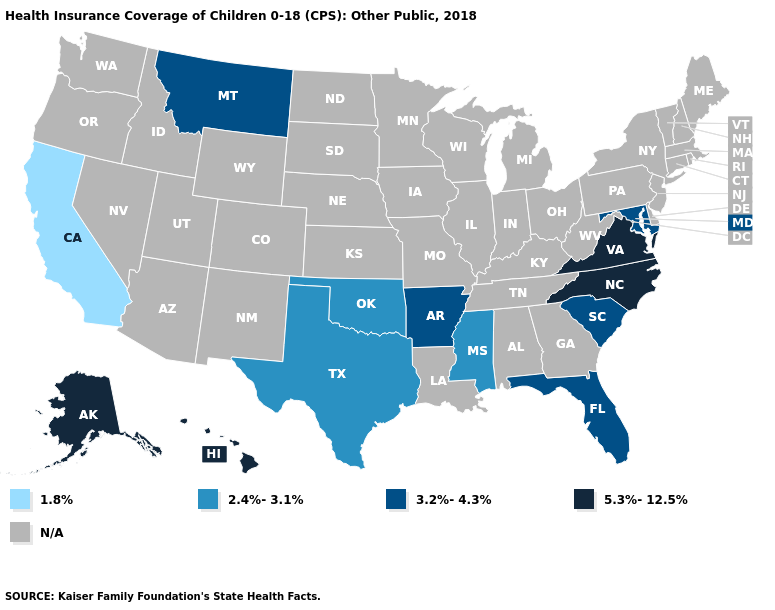What is the highest value in the USA?
Be succinct. 5.3%-12.5%. What is the value of Iowa?
Write a very short answer. N/A. Does North Carolina have the highest value in the USA?
Write a very short answer. Yes. What is the value of Iowa?
Concise answer only. N/A. What is the highest value in the USA?
Answer briefly. 5.3%-12.5%. What is the highest value in the USA?
Answer briefly. 5.3%-12.5%. Among the states that border Virginia , does Maryland have the highest value?
Keep it brief. No. What is the value of Montana?
Answer briefly. 3.2%-4.3%. What is the value of Wisconsin?
Be succinct. N/A. Name the states that have a value in the range 3.2%-4.3%?
Be succinct. Arkansas, Florida, Maryland, Montana, South Carolina. Does the map have missing data?
Answer briefly. Yes. Which states have the lowest value in the West?
Short answer required. California. 